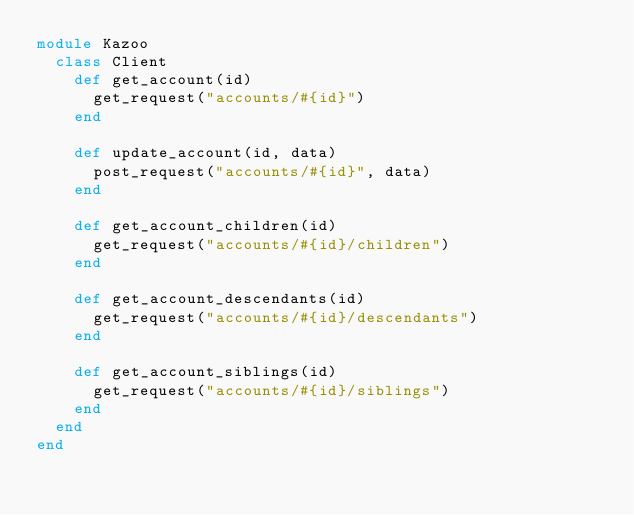<code> <loc_0><loc_0><loc_500><loc_500><_Ruby_>module Kazoo
  class Client
    def get_account(id)
      get_request("accounts/#{id}")
    end

    def update_account(id, data)
      post_request("accounts/#{id}", data)
    end

    def get_account_children(id)
      get_request("accounts/#{id}/children")
    end

    def get_account_descendants(id)
      get_request("accounts/#{id}/descendants")
    end

    def get_account_siblings(id)
      get_request("accounts/#{id}/siblings")
    end
  end
end
</code> 